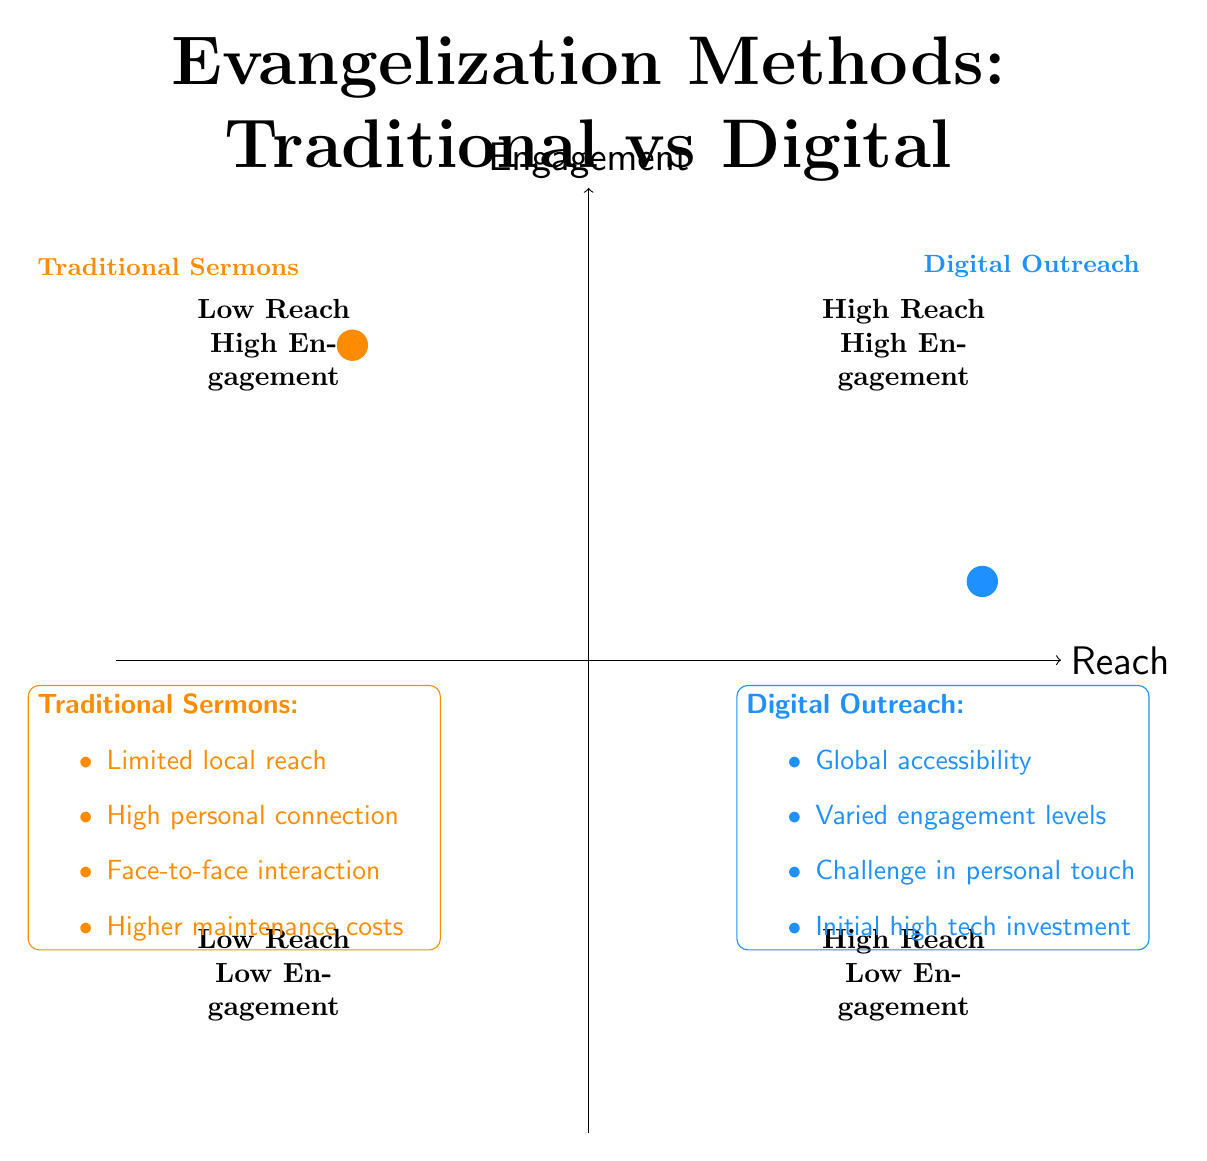What is the main category of the element located in the upper-left quadrant? The upper-left quadrant represents elements with high engagement but low reach, which is characteristic of traditional methods such as sermons. Thus, the main category is "traditional."
Answer: traditional How many elements are represented in the diagram? The data lists a total of eight distinct elements regarding traditional sermons and digital outreach, contributing to the assessment of evangelization effectiveness.
Answer: eight Which method has higher reach according to the chart? The digital outreach method is plotted in the quadrant that indicates it has a higher reach compared to traditional sermons, which have limited reach to local congregations.
Answer: Digital Outreach What factor indicates a higher personal touch in evangelization methods? Traditional sermons provide a higher personal interaction through face-to-face contact, placing them above digital outreach, which faces challenges in maintaining a personal touch.
Answer: Traditional Sermons What are the two factors analyzed in the quadrant chart? The two main factors analyzed are "reach" and "engagement," which provide insight into the effectiveness of various evangelization methods.
Answer: reach and engagement Which method has lower initial costs according to the chart's data? Traditional sermons have lower technological costs but incur higher maintenance costs, while digital outreach has high initial investment costs, indicating that traditional sermons are less costly upfront.
Answer: Traditional Sermons In which quadrant is digital outreach placed, considering its reach and engagement? Digital outreach is placed in the lower-right quadrant, which is indicative of high reach but relatively lower levels of engagement compared to traditional sermons.
Answer: High Reach Low Engagement 